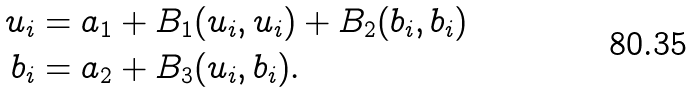<formula> <loc_0><loc_0><loc_500><loc_500>u _ { i } & = a _ { 1 } + B _ { 1 } ( u _ { i } , u _ { i } ) + B _ { 2 } ( b _ { i } , b _ { i } ) \\ b _ { i } & = a _ { 2 } + B _ { 3 } ( u _ { i } , b _ { i } ) .</formula> 